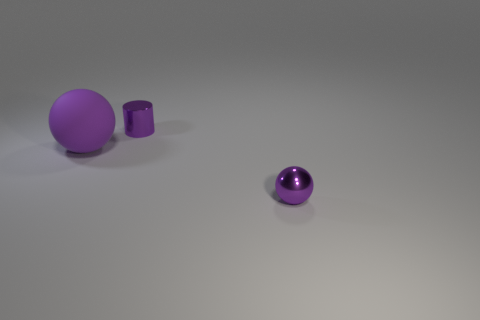Can you describe the lighting and shadows seen in the image? The lighting in the image appears to be coming from the top left, as evidenced by shadows cast to the bottom right of the objects. The large sphere casts a broad, diffused shadow, whereas the shadows of the small cylinder and sphere are sharper and more defined, indicating a light source that is possibly closer or more direct. 